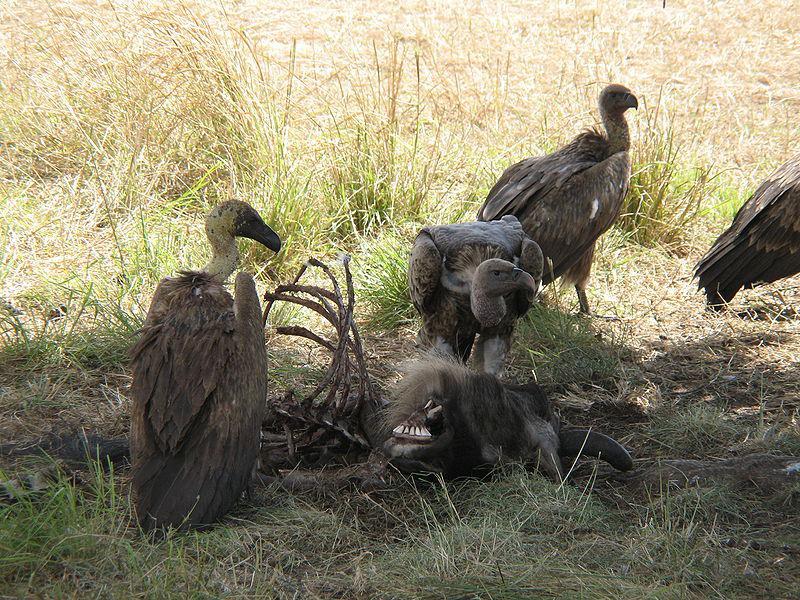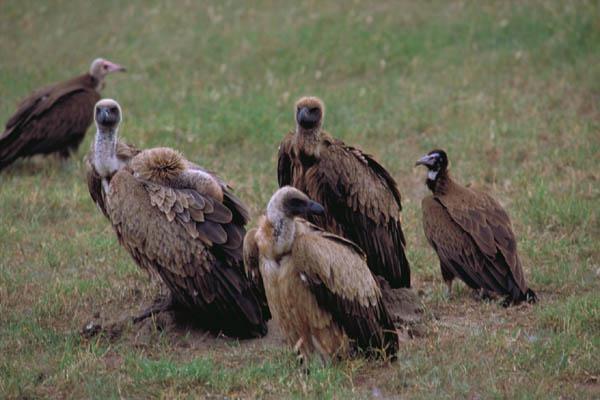The first image is the image on the left, the second image is the image on the right. Examine the images to the left and right. Is the description "An image shows multiple brown vultures around a ribcage." accurate? Answer yes or no. Yes. The first image is the image on the left, the second image is the image on the right. For the images shown, is this caption "One of the images shows the bones from the rib cage of a dead animal." true? Answer yes or no. Yes. 